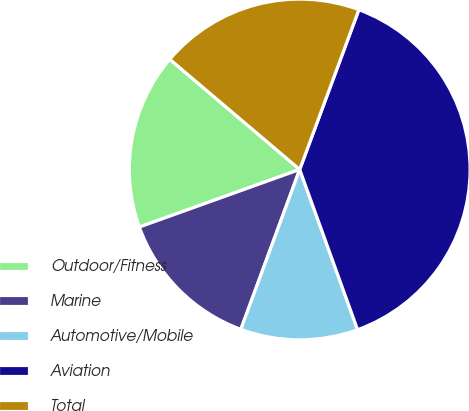<chart> <loc_0><loc_0><loc_500><loc_500><pie_chart><fcel>Outdoor/Fitness<fcel>Marine<fcel>Automotive/Mobile<fcel>Aviation<fcel>Total<nl><fcel>16.68%<fcel>13.9%<fcel>11.13%<fcel>38.84%<fcel>19.45%<nl></chart> 